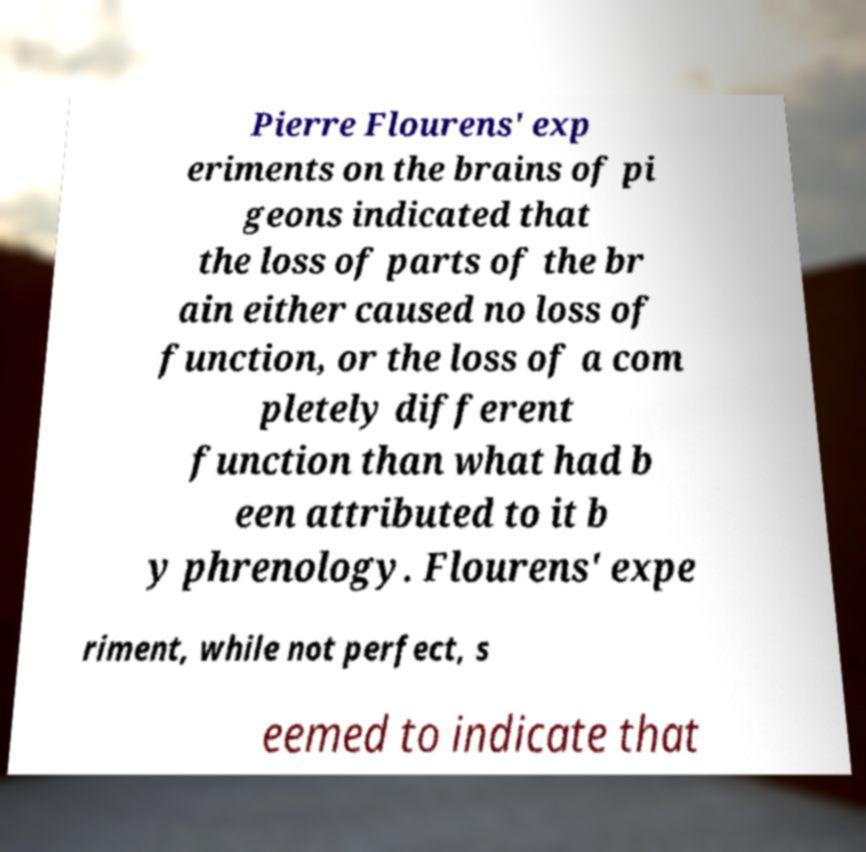What messages or text are displayed in this image? I need them in a readable, typed format. Pierre Flourens' exp eriments on the brains of pi geons indicated that the loss of parts of the br ain either caused no loss of function, or the loss of a com pletely different function than what had b een attributed to it b y phrenology. Flourens' expe riment, while not perfect, s eemed to indicate that 